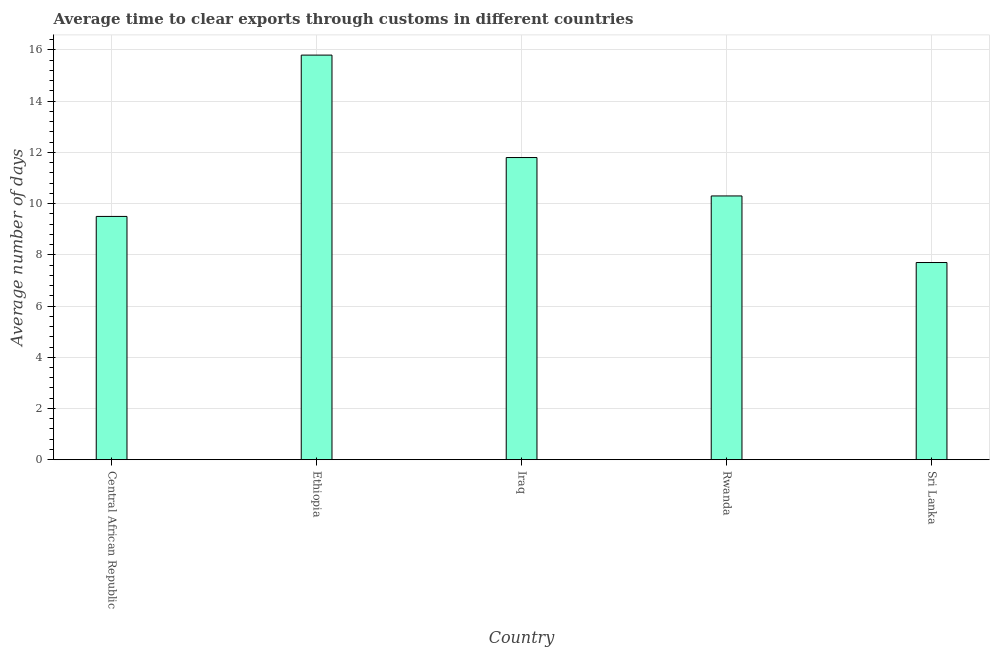Does the graph contain any zero values?
Provide a short and direct response. No. Does the graph contain grids?
Keep it short and to the point. Yes. What is the title of the graph?
Give a very brief answer. Average time to clear exports through customs in different countries. What is the label or title of the X-axis?
Your response must be concise. Country. What is the label or title of the Y-axis?
Offer a terse response. Average number of days. What is the time to clear exports through customs in Central African Republic?
Your answer should be compact. 9.5. Across all countries, what is the maximum time to clear exports through customs?
Provide a short and direct response. 15.8. In which country was the time to clear exports through customs maximum?
Give a very brief answer. Ethiopia. In which country was the time to clear exports through customs minimum?
Ensure brevity in your answer.  Sri Lanka. What is the sum of the time to clear exports through customs?
Ensure brevity in your answer.  55.1. What is the difference between the time to clear exports through customs in Iraq and Rwanda?
Provide a short and direct response. 1.5. What is the average time to clear exports through customs per country?
Provide a short and direct response. 11.02. What is the ratio of the time to clear exports through customs in Ethiopia to that in Sri Lanka?
Keep it short and to the point. 2.05. Is the time to clear exports through customs in Iraq less than that in Rwanda?
Make the answer very short. No. Is the difference between the time to clear exports through customs in Iraq and Sri Lanka greater than the difference between any two countries?
Your answer should be compact. No. What is the difference between the highest and the second highest time to clear exports through customs?
Make the answer very short. 4. Is the sum of the time to clear exports through customs in Ethiopia and Rwanda greater than the maximum time to clear exports through customs across all countries?
Give a very brief answer. Yes. In how many countries, is the time to clear exports through customs greater than the average time to clear exports through customs taken over all countries?
Give a very brief answer. 2. How many bars are there?
Ensure brevity in your answer.  5. What is the difference between two consecutive major ticks on the Y-axis?
Your answer should be very brief. 2. Are the values on the major ticks of Y-axis written in scientific E-notation?
Offer a terse response. No. What is the Average number of days of Central African Republic?
Your response must be concise. 9.5. What is the Average number of days of Ethiopia?
Your answer should be very brief. 15.8. What is the Average number of days in Iraq?
Offer a very short reply. 11.8. What is the Average number of days of Rwanda?
Offer a terse response. 10.3. What is the Average number of days in Sri Lanka?
Ensure brevity in your answer.  7.7. What is the difference between the Average number of days in Central African Republic and Ethiopia?
Keep it short and to the point. -6.3. What is the difference between the Average number of days in Central African Republic and Sri Lanka?
Your answer should be compact. 1.8. What is the difference between the Average number of days in Ethiopia and Iraq?
Provide a short and direct response. 4. What is the difference between the Average number of days in Iraq and Sri Lanka?
Offer a terse response. 4.1. What is the ratio of the Average number of days in Central African Republic to that in Ethiopia?
Make the answer very short. 0.6. What is the ratio of the Average number of days in Central African Republic to that in Iraq?
Give a very brief answer. 0.81. What is the ratio of the Average number of days in Central African Republic to that in Rwanda?
Keep it short and to the point. 0.92. What is the ratio of the Average number of days in Central African Republic to that in Sri Lanka?
Offer a terse response. 1.23. What is the ratio of the Average number of days in Ethiopia to that in Iraq?
Your answer should be very brief. 1.34. What is the ratio of the Average number of days in Ethiopia to that in Rwanda?
Offer a terse response. 1.53. What is the ratio of the Average number of days in Ethiopia to that in Sri Lanka?
Ensure brevity in your answer.  2.05. What is the ratio of the Average number of days in Iraq to that in Rwanda?
Keep it short and to the point. 1.15. What is the ratio of the Average number of days in Iraq to that in Sri Lanka?
Your answer should be very brief. 1.53. What is the ratio of the Average number of days in Rwanda to that in Sri Lanka?
Give a very brief answer. 1.34. 